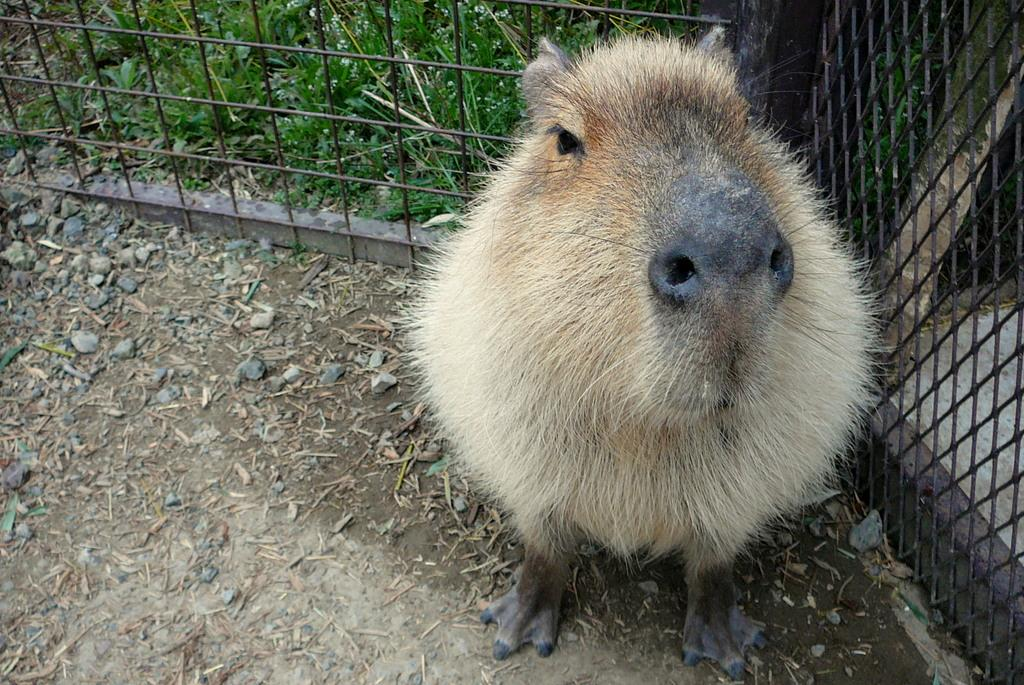What type of creature is in the image? There is an animal in the image. Where is the animal located? The animal is on the ground. What is behind the animal? There is a fencing behind the animal. What is visible beyond the fencing? There is grass behind the fencing. What type of locket is the man wearing in the image? There is no man or locket present in the image; it features an animal on the ground with a fencing and grass behind it. 